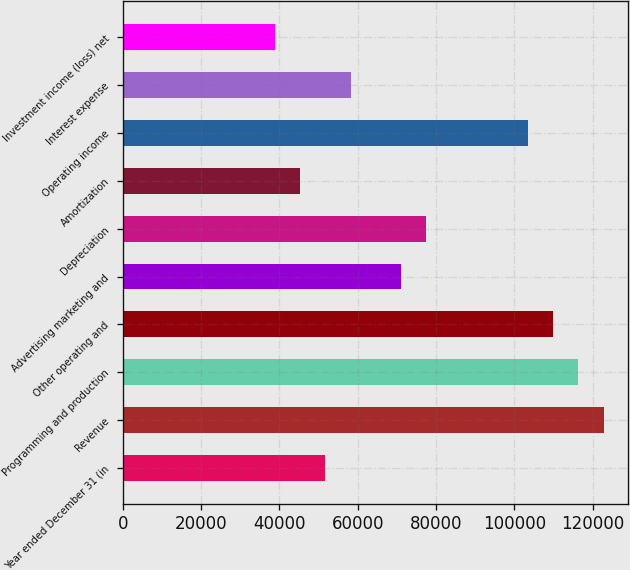<chart> <loc_0><loc_0><loc_500><loc_500><bar_chart><fcel>Year ended December 31 (in<fcel>Revenue<fcel>Programming and production<fcel>Other operating and<fcel>Advertising marketing and<fcel>Depreciation<fcel>Amortization<fcel>Operating income<fcel>Interest expense<fcel>Investment income (loss) net<nl><fcel>51725.7<fcel>122848<fcel>116382<fcel>109916<fcel>71122.6<fcel>77588.2<fcel>45260.1<fcel>103451<fcel>58191.4<fcel>38794.5<nl></chart> 